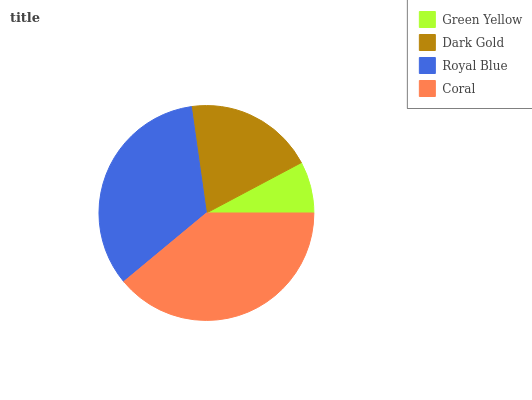Is Green Yellow the minimum?
Answer yes or no. Yes. Is Coral the maximum?
Answer yes or no. Yes. Is Dark Gold the minimum?
Answer yes or no. No. Is Dark Gold the maximum?
Answer yes or no. No. Is Dark Gold greater than Green Yellow?
Answer yes or no. Yes. Is Green Yellow less than Dark Gold?
Answer yes or no. Yes. Is Green Yellow greater than Dark Gold?
Answer yes or no. No. Is Dark Gold less than Green Yellow?
Answer yes or no. No. Is Royal Blue the high median?
Answer yes or no. Yes. Is Dark Gold the low median?
Answer yes or no. Yes. Is Green Yellow the high median?
Answer yes or no. No. Is Coral the low median?
Answer yes or no. No. 